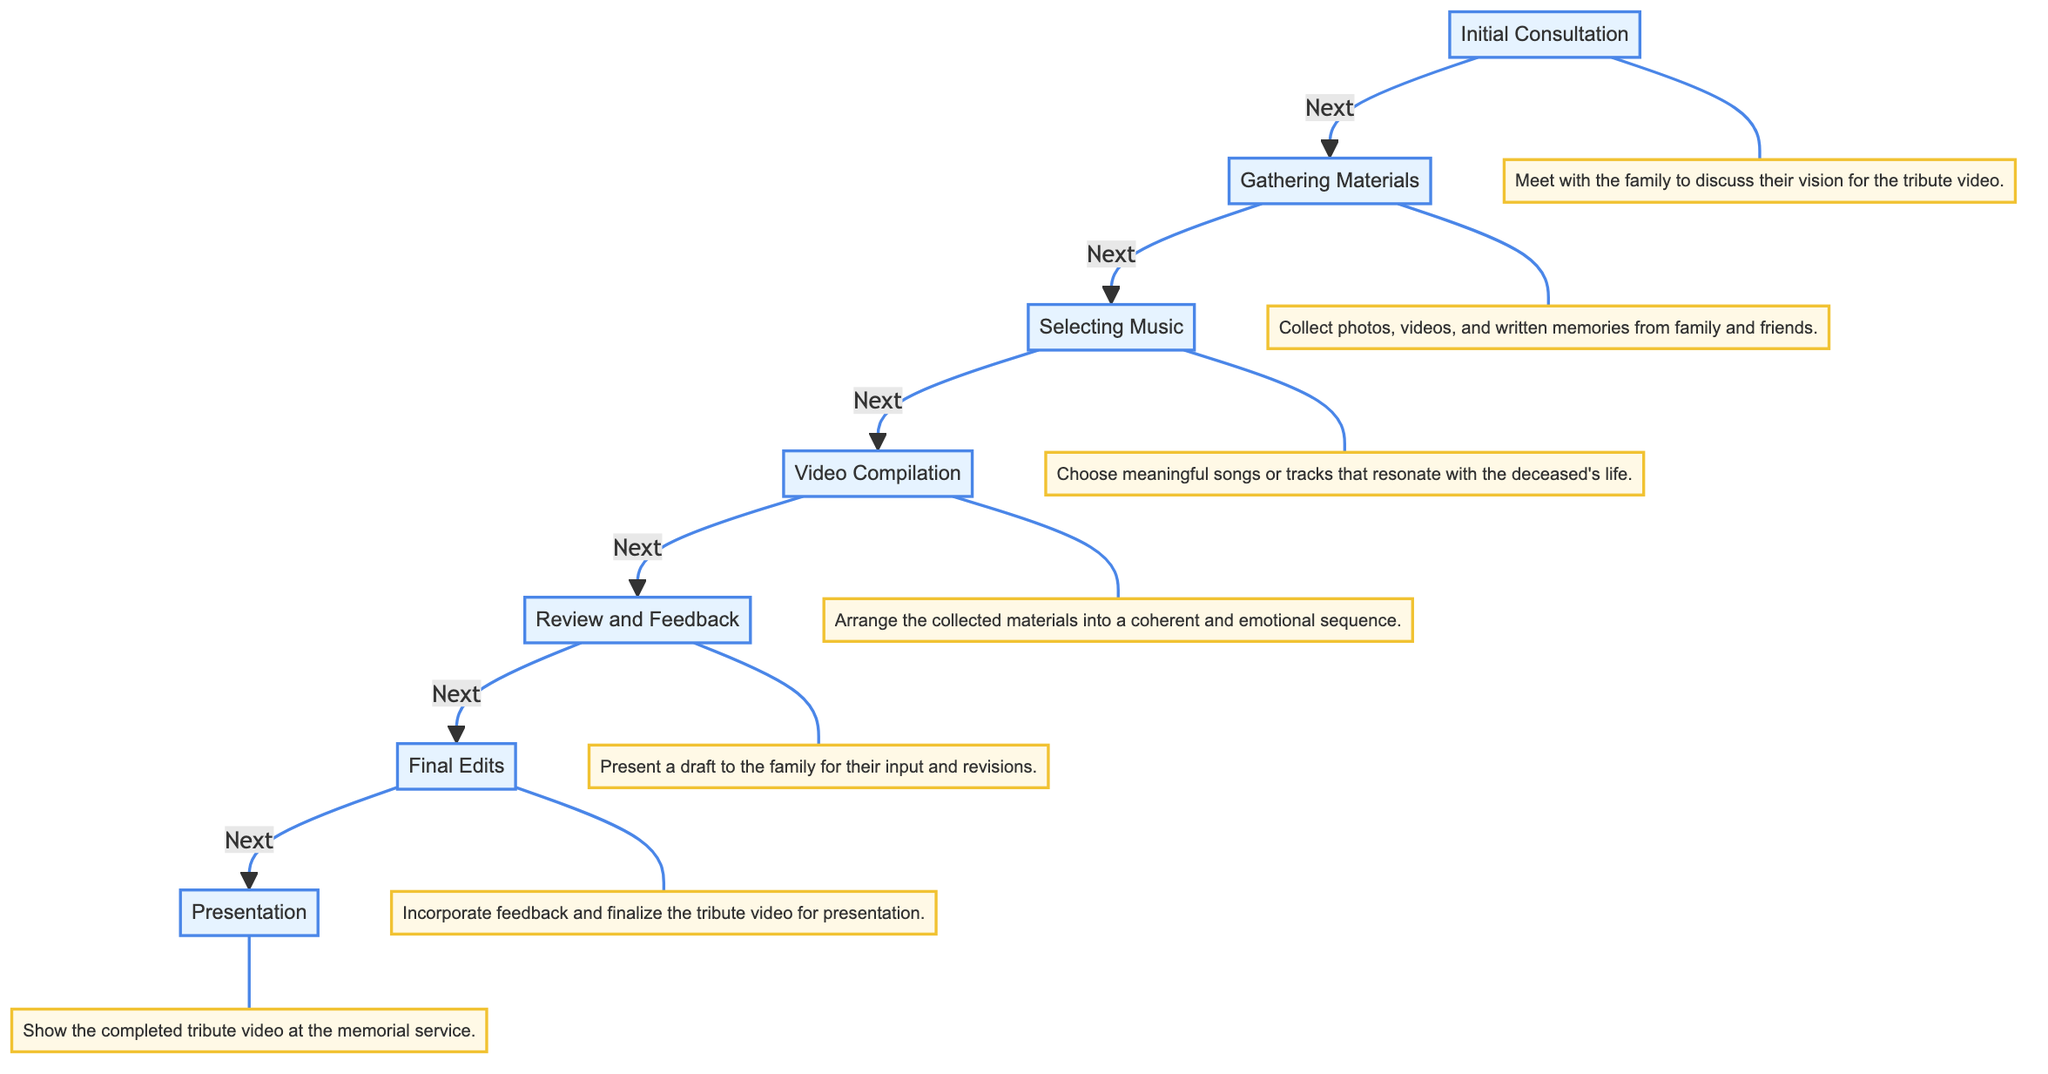What is the first step in creating a tribute video? The diagram shows "Initial Consultation" as the starting point, indicating that the process begins with meeting the family to discuss their vision for the tribute video.
Answer: Initial Consultation How many steps are there in total? By counting the steps listed in the flowchart, we see there are seven distinct processes involved in creating a personalized tribute video.
Answer: 7 What follows the "Gathering Materials" step? The flowchart indicates that the next step after "Gathering Materials" is "Selecting Music," showing the sequential nature of these processes.
Answer: Selecting Music Which step includes presenting a draft for family input? "Review and Feedback" is the step where the draft of the tribute video is presented to the family for their input and revisions, as shown in the flowchart.
Answer: Review and Feedback What is the final step before the presentation? According to the flowchart, "Final Edits" is the step that precedes the "Presentation," meaning feedback is incorporated before showing the completed video.
Answer: Final Edits Describe the content of the "Video Compilation" step. In the flowchart, "Video Compilation" is described as the process of arranging collected materials into a coherent and emotional sequence, highlighting its importance in the overall creation process.
Answer: Arrange materials Which step comes directly after "Selecting Music"? The flowchart shows that "Video Compilation" comes directly after "Selecting Music," indicating the continuation of the process in this order.
Answer: Video Compilation What is the last action depicted in the diagram? The final action depicted in the diagram is "Show the completed tribute video at the memorial service," which represents the culmination of all previous steps.
Answer: Presentation What type of materials are gathered in the second step? The "Gathering Materials" step specifically mentions collecting photos, videos, and written memories, indicating the types of content needed for the tribute video.
Answer: Photos, videos, memories 